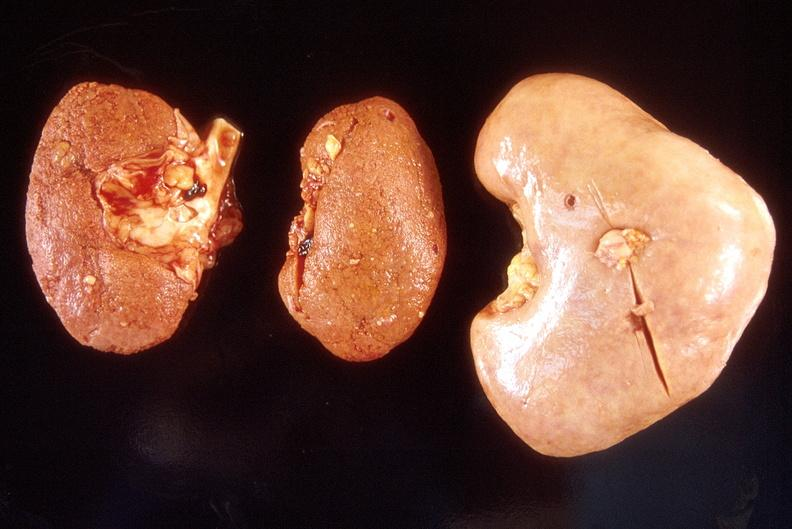where is this?
Answer the question using a single word or phrase. Urinary 